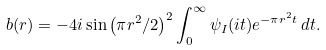Convert formula to latex. <formula><loc_0><loc_0><loc_500><loc_500>b ( r ) = - 4 i \sin \left ( \pi r ^ { 2 } / 2 \right ) ^ { 2 } \int _ { 0 } ^ { \infty } \psi _ { I } ( i t ) e ^ { - \pi r ^ { 2 } t } \, d t .</formula> 